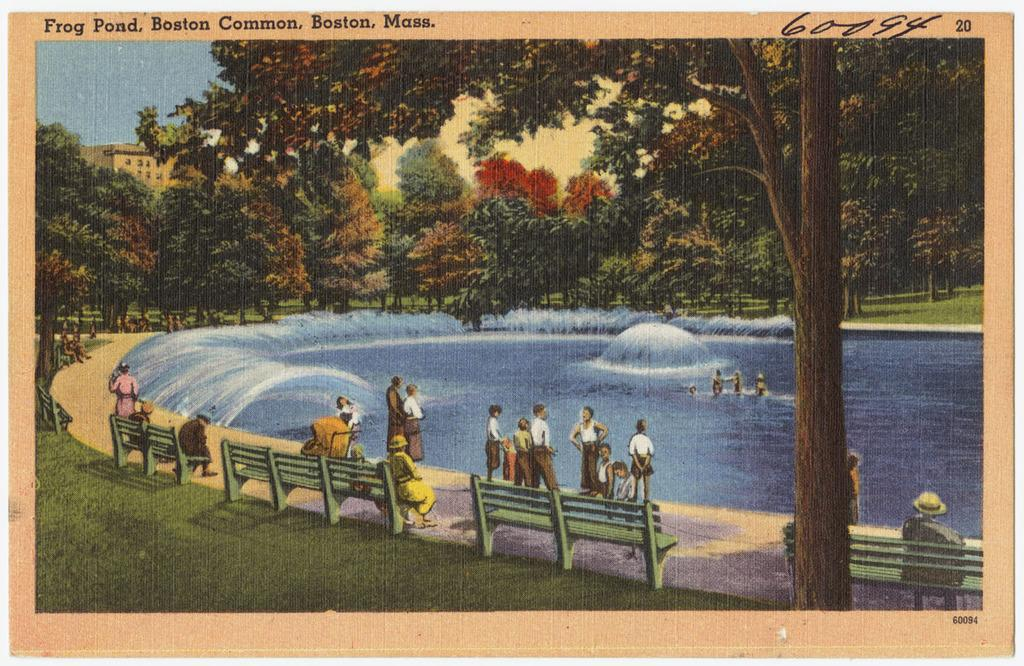<image>
Provide a brief description of the given image. A postcard that features a pond in Boston. 